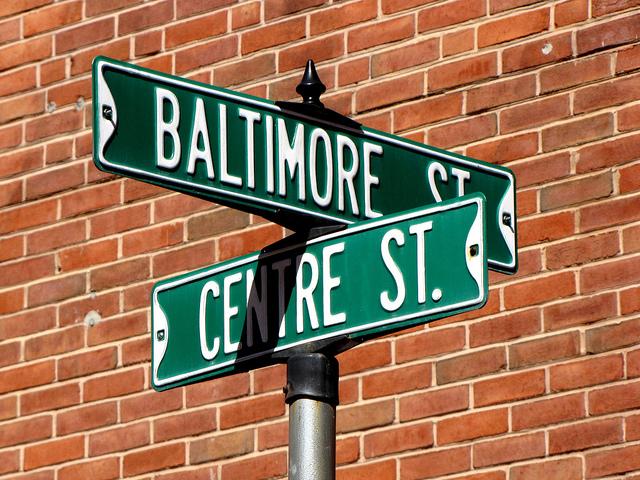What is the wall behind the sign composed of?
Keep it brief. Brick. What do the signs read?
Concise answer only. Baltimore st and center st. Is the sign on the top named after a country?
Give a very brief answer. No. 